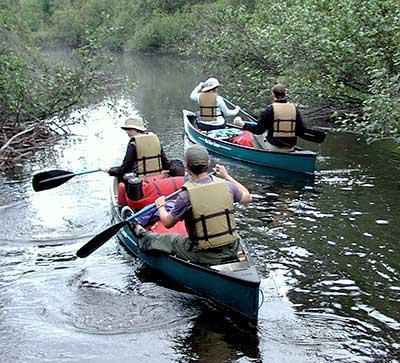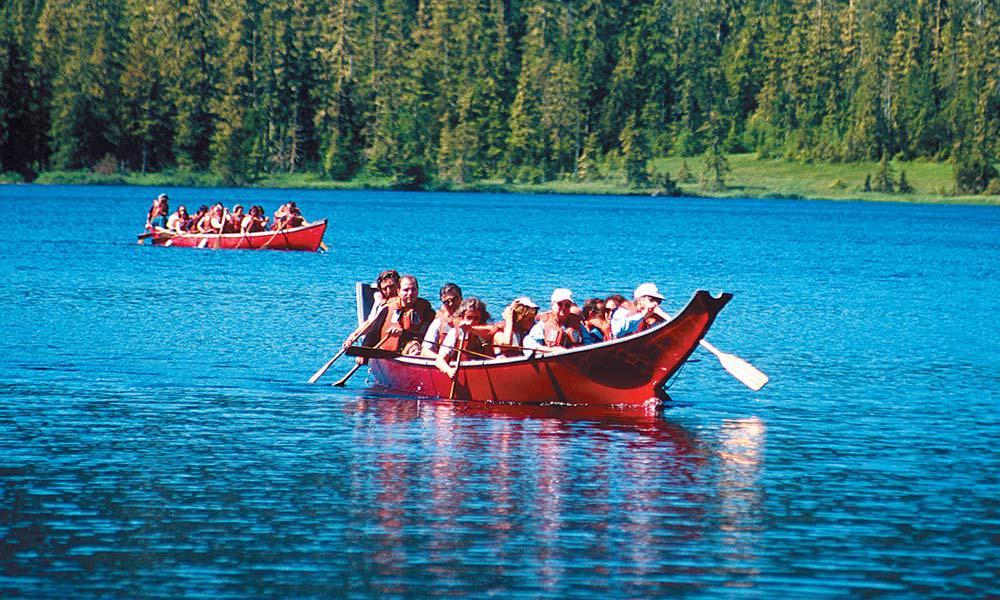The first image is the image on the left, the second image is the image on the right. Evaluate the accuracy of this statement regarding the images: "The left and right image contains a total of two boats.". Is it true? Answer yes or no. No. 